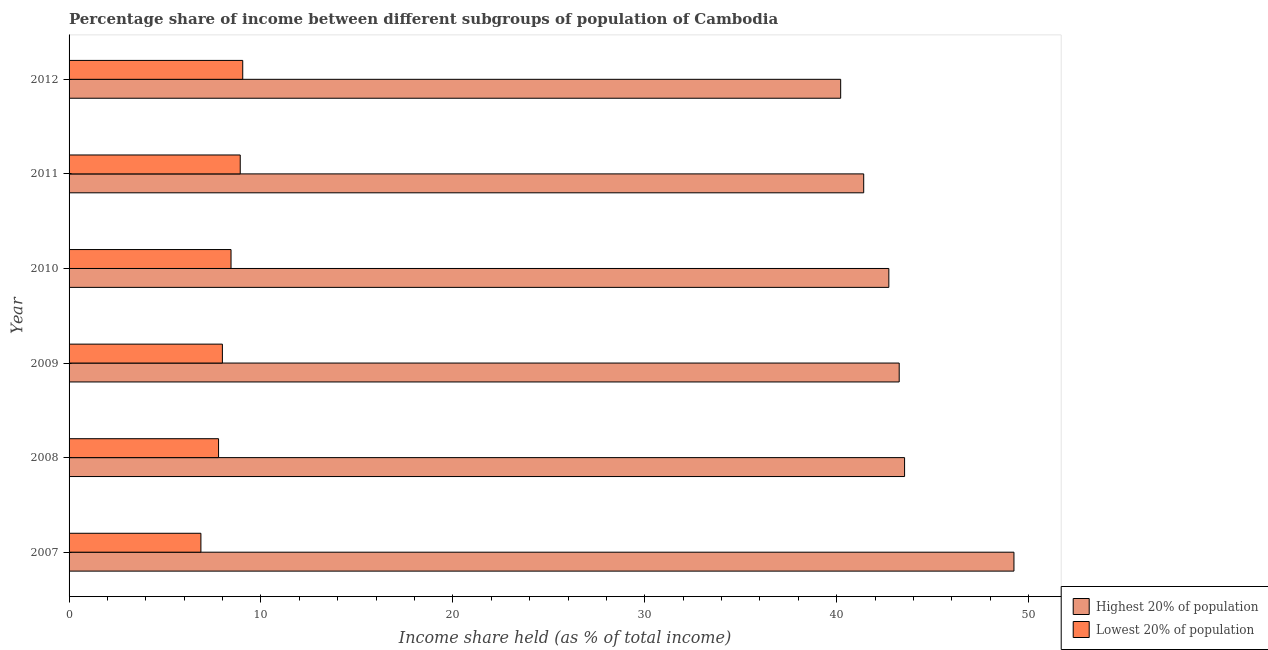How many different coloured bars are there?
Give a very brief answer. 2. Are the number of bars per tick equal to the number of legend labels?
Offer a terse response. Yes. Are the number of bars on each tick of the Y-axis equal?
Make the answer very short. Yes. How many bars are there on the 6th tick from the top?
Provide a short and direct response. 2. How many bars are there on the 5th tick from the bottom?
Offer a terse response. 2. What is the income share held by highest 20% of the population in 2012?
Your answer should be very brief. 40.21. Across all years, what is the maximum income share held by highest 20% of the population?
Ensure brevity in your answer.  49.24. Across all years, what is the minimum income share held by lowest 20% of the population?
Your response must be concise. 6.87. In which year was the income share held by lowest 20% of the population minimum?
Provide a succinct answer. 2007. What is the total income share held by lowest 20% of the population in the graph?
Give a very brief answer. 49.06. What is the difference between the income share held by highest 20% of the population in 2007 and that in 2011?
Your answer should be very brief. 7.83. What is the difference between the income share held by lowest 20% of the population in 2010 and the income share held by highest 20% of the population in 2007?
Provide a succinct answer. -40.8. What is the average income share held by lowest 20% of the population per year?
Ensure brevity in your answer.  8.18. In the year 2008, what is the difference between the income share held by lowest 20% of the population and income share held by highest 20% of the population?
Provide a short and direct response. -35.75. In how many years, is the income share held by highest 20% of the population greater than 34 %?
Give a very brief answer. 6. What is the ratio of the income share held by lowest 20% of the population in 2007 to that in 2009?
Your answer should be compact. 0.86. Is the income share held by highest 20% of the population in 2008 less than that in 2009?
Your answer should be compact. No. Is the difference between the income share held by highest 20% of the population in 2007 and 2012 greater than the difference between the income share held by lowest 20% of the population in 2007 and 2012?
Your answer should be compact. Yes. What is the difference between the highest and the second highest income share held by lowest 20% of the population?
Make the answer very short. 0.13. What is the difference between the highest and the lowest income share held by highest 20% of the population?
Give a very brief answer. 9.03. In how many years, is the income share held by lowest 20% of the population greater than the average income share held by lowest 20% of the population taken over all years?
Keep it short and to the point. 3. Is the sum of the income share held by lowest 20% of the population in 2007 and 2009 greater than the maximum income share held by highest 20% of the population across all years?
Keep it short and to the point. No. What does the 2nd bar from the top in 2009 represents?
Your answer should be very brief. Highest 20% of population. What does the 2nd bar from the bottom in 2011 represents?
Your answer should be very brief. Lowest 20% of population. Are all the bars in the graph horizontal?
Your response must be concise. Yes. What is the difference between two consecutive major ticks on the X-axis?
Offer a very short reply. 10. Are the values on the major ticks of X-axis written in scientific E-notation?
Ensure brevity in your answer.  No. Does the graph contain any zero values?
Your answer should be compact. No. How many legend labels are there?
Provide a succinct answer. 2. What is the title of the graph?
Your response must be concise. Percentage share of income between different subgroups of population of Cambodia. Does "Secondary Education" appear as one of the legend labels in the graph?
Provide a short and direct response. No. What is the label or title of the X-axis?
Ensure brevity in your answer.  Income share held (as % of total income). What is the Income share held (as % of total income) of Highest 20% of population in 2007?
Your answer should be compact. 49.24. What is the Income share held (as % of total income) in Lowest 20% of population in 2007?
Give a very brief answer. 6.87. What is the Income share held (as % of total income) in Highest 20% of population in 2008?
Provide a short and direct response. 43.54. What is the Income share held (as % of total income) of Lowest 20% of population in 2008?
Make the answer very short. 7.79. What is the Income share held (as % of total income) of Highest 20% of population in 2009?
Offer a terse response. 43.26. What is the Income share held (as % of total income) in Lowest 20% of population in 2009?
Your answer should be very brief. 7.99. What is the Income share held (as % of total income) in Highest 20% of population in 2010?
Keep it short and to the point. 42.72. What is the Income share held (as % of total income) of Lowest 20% of population in 2010?
Offer a terse response. 8.44. What is the Income share held (as % of total income) in Highest 20% of population in 2011?
Your answer should be compact. 41.41. What is the Income share held (as % of total income) in Lowest 20% of population in 2011?
Your answer should be compact. 8.92. What is the Income share held (as % of total income) in Highest 20% of population in 2012?
Your response must be concise. 40.21. What is the Income share held (as % of total income) in Lowest 20% of population in 2012?
Offer a terse response. 9.05. Across all years, what is the maximum Income share held (as % of total income) of Highest 20% of population?
Provide a succinct answer. 49.24. Across all years, what is the maximum Income share held (as % of total income) of Lowest 20% of population?
Your response must be concise. 9.05. Across all years, what is the minimum Income share held (as % of total income) in Highest 20% of population?
Offer a very short reply. 40.21. Across all years, what is the minimum Income share held (as % of total income) in Lowest 20% of population?
Make the answer very short. 6.87. What is the total Income share held (as % of total income) of Highest 20% of population in the graph?
Give a very brief answer. 260.38. What is the total Income share held (as % of total income) of Lowest 20% of population in the graph?
Ensure brevity in your answer.  49.06. What is the difference between the Income share held (as % of total income) in Lowest 20% of population in 2007 and that in 2008?
Your answer should be very brief. -0.92. What is the difference between the Income share held (as % of total income) in Highest 20% of population in 2007 and that in 2009?
Your answer should be very brief. 5.98. What is the difference between the Income share held (as % of total income) in Lowest 20% of population in 2007 and that in 2009?
Offer a terse response. -1.12. What is the difference between the Income share held (as % of total income) of Highest 20% of population in 2007 and that in 2010?
Provide a succinct answer. 6.52. What is the difference between the Income share held (as % of total income) in Lowest 20% of population in 2007 and that in 2010?
Your response must be concise. -1.57. What is the difference between the Income share held (as % of total income) in Highest 20% of population in 2007 and that in 2011?
Ensure brevity in your answer.  7.83. What is the difference between the Income share held (as % of total income) in Lowest 20% of population in 2007 and that in 2011?
Provide a short and direct response. -2.05. What is the difference between the Income share held (as % of total income) in Highest 20% of population in 2007 and that in 2012?
Your answer should be compact. 9.03. What is the difference between the Income share held (as % of total income) of Lowest 20% of population in 2007 and that in 2012?
Your response must be concise. -2.18. What is the difference between the Income share held (as % of total income) of Highest 20% of population in 2008 and that in 2009?
Make the answer very short. 0.28. What is the difference between the Income share held (as % of total income) of Highest 20% of population in 2008 and that in 2010?
Your answer should be very brief. 0.82. What is the difference between the Income share held (as % of total income) of Lowest 20% of population in 2008 and that in 2010?
Give a very brief answer. -0.65. What is the difference between the Income share held (as % of total income) of Highest 20% of population in 2008 and that in 2011?
Make the answer very short. 2.13. What is the difference between the Income share held (as % of total income) in Lowest 20% of population in 2008 and that in 2011?
Keep it short and to the point. -1.13. What is the difference between the Income share held (as % of total income) of Highest 20% of population in 2008 and that in 2012?
Ensure brevity in your answer.  3.33. What is the difference between the Income share held (as % of total income) in Lowest 20% of population in 2008 and that in 2012?
Your response must be concise. -1.26. What is the difference between the Income share held (as % of total income) of Highest 20% of population in 2009 and that in 2010?
Your answer should be compact. 0.54. What is the difference between the Income share held (as % of total income) of Lowest 20% of population in 2009 and that in 2010?
Provide a succinct answer. -0.45. What is the difference between the Income share held (as % of total income) of Highest 20% of population in 2009 and that in 2011?
Give a very brief answer. 1.85. What is the difference between the Income share held (as % of total income) in Lowest 20% of population in 2009 and that in 2011?
Keep it short and to the point. -0.93. What is the difference between the Income share held (as % of total income) of Highest 20% of population in 2009 and that in 2012?
Give a very brief answer. 3.05. What is the difference between the Income share held (as % of total income) in Lowest 20% of population in 2009 and that in 2012?
Your response must be concise. -1.06. What is the difference between the Income share held (as % of total income) of Highest 20% of population in 2010 and that in 2011?
Your answer should be compact. 1.31. What is the difference between the Income share held (as % of total income) of Lowest 20% of population in 2010 and that in 2011?
Provide a succinct answer. -0.48. What is the difference between the Income share held (as % of total income) of Highest 20% of population in 2010 and that in 2012?
Your answer should be compact. 2.51. What is the difference between the Income share held (as % of total income) of Lowest 20% of population in 2010 and that in 2012?
Offer a terse response. -0.61. What is the difference between the Income share held (as % of total income) of Highest 20% of population in 2011 and that in 2012?
Keep it short and to the point. 1.2. What is the difference between the Income share held (as % of total income) in Lowest 20% of population in 2011 and that in 2012?
Your answer should be very brief. -0.13. What is the difference between the Income share held (as % of total income) in Highest 20% of population in 2007 and the Income share held (as % of total income) in Lowest 20% of population in 2008?
Give a very brief answer. 41.45. What is the difference between the Income share held (as % of total income) of Highest 20% of population in 2007 and the Income share held (as % of total income) of Lowest 20% of population in 2009?
Make the answer very short. 41.25. What is the difference between the Income share held (as % of total income) in Highest 20% of population in 2007 and the Income share held (as % of total income) in Lowest 20% of population in 2010?
Offer a very short reply. 40.8. What is the difference between the Income share held (as % of total income) of Highest 20% of population in 2007 and the Income share held (as % of total income) of Lowest 20% of population in 2011?
Make the answer very short. 40.32. What is the difference between the Income share held (as % of total income) in Highest 20% of population in 2007 and the Income share held (as % of total income) in Lowest 20% of population in 2012?
Your answer should be compact. 40.19. What is the difference between the Income share held (as % of total income) in Highest 20% of population in 2008 and the Income share held (as % of total income) in Lowest 20% of population in 2009?
Provide a succinct answer. 35.55. What is the difference between the Income share held (as % of total income) in Highest 20% of population in 2008 and the Income share held (as % of total income) in Lowest 20% of population in 2010?
Your response must be concise. 35.1. What is the difference between the Income share held (as % of total income) in Highest 20% of population in 2008 and the Income share held (as % of total income) in Lowest 20% of population in 2011?
Ensure brevity in your answer.  34.62. What is the difference between the Income share held (as % of total income) of Highest 20% of population in 2008 and the Income share held (as % of total income) of Lowest 20% of population in 2012?
Ensure brevity in your answer.  34.49. What is the difference between the Income share held (as % of total income) in Highest 20% of population in 2009 and the Income share held (as % of total income) in Lowest 20% of population in 2010?
Give a very brief answer. 34.82. What is the difference between the Income share held (as % of total income) of Highest 20% of population in 2009 and the Income share held (as % of total income) of Lowest 20% of population in 2011?
Ensure brevity in your answer.  34.34. What is the difference between the Income share held (as % of total income) in Highest 20% of population in 2009 and the Income share held (as % of total income) in Lowest 20% of population in 2012?
Give a very brief answer. 34.21. What is the difference between the Income share held (as % of total income) of Highest 20% of population in 2010 and the Income share held (as % of total income) of Lowest 20% of population in 2011?
Provide a succinct answer. 33.8. What is the difference between the Income share held (as % of total income) of Highest 20% of population in 2010 and the Income share held (as % of total income) of Lowest 20% of population in 2012?
Your answer should be very brief. 33.67. What is the difference between the Income share held (as % of total income) of Highest 20% of population in 2011 and the Income share held (as % of total income) of Lowest 20% of population in 2012?
Your answer should be very brief. 32.36. What is the average Income share held (as % of total income) in Highest 20% of population per year?
Offer a very short reply. 43.4. What is the average Income share held (as % of total income) in Lowest 20% of population per year?
Offer a very short reply. 8.18. In the year 2007, what is the difference between the Income share held (as % of total income) in Highest 20% of population and Income share held (as % of total income) in Lowest 20% of population?
Your response must be concise. 42.37. In the year 2008, what is the difference between the Income share held (as % of total income) of Highest 20% of population and Income share held (as % of total income) of Lowest 20% of population?
Give a very brief answer. 35.75. In the year 2009, what is the difference between the Income share held (as % of total income) of Highest 20% of population and Income share held (as % of total income) of Lowest 20% of population?
Offer a very short reply. 35.27. In the year 2010, what is the difference between the Income share held (as % of total income) in Highest 20% of population and Income share held (as % of total income) in Lowest 20% of population?
Your answer should be very brief. 34.28. In the year 2011, what is the difference between the Income share held (as % of total income) in Highest 20% of population and Income share held (as % of total income) in Lowest 20% of population?
Make the answer very short. 32.49. In the year 2012, what is the difference between the Income share held (as % of total income) in Highest 20% of population and Income share held (as % of total income) in Lowest 20% of population?
Your answer should be very brief. 31.16. What is the ratio of the Income share held (as % of total income) of Highest 20% of population in 2007 to that in 2008?
Provide a succinct answer. 1.13. What is the ratio of the Income share held (as % of total income) in Lowest 20% of population in 2007 to that in 2008?
Offer a very short reply. 0.88. What is the ratio of the Income share held (as % of total income) of Highest 20% of population in 2007 to that in 2009?
Your response must be concise. 1.14. What is the ratio of the Income share held (as % of total income) in Lowest 20% of population in 2007 to that in 2009?
Your answer should be compact. 0.86. What is the ratio of the Income share held (as % of total income) of Highest 20% of population in 2007 to that in 2010?
Give a very brief answer. 1.15. What is the ratio of the Income share held (as % of total income) in Lowest 20% of population in 2007 to that in 2010?
Provide a short and direct response. 0.81. What is the ratio of the Income share held (as % of total income) in Highest 20% of population in 2007 to that in 2011?
Your response must be concise. 1.19. What is the ratio of the Income share held (as % of total income) of Lowest 20% of population in 2007 to that in 2011?
Provide a succinct answer. 0.77. What is the ratio of the Income share held (as % of total income) of Highest 20% of population in 2007 to that in 2012?
Keep it short and to the point. 1.22. What is the ratio of the Income share held (as % of total income) in Lowest 20% of population in 2007 to that in 2012?
Your response must be concise. 0.76. What is the ratio of the Income share held (as % of total income) in Lowest 20% of population in 2008 to that in 2009?
Keep it short and to the point. 0.97. What is the ratio of the Income share held (as % of total income) in Highest 20% of population in 2008 to that in 2010?
Your answer should be very brief. 1.02. What is the ratio of the Income share held (as % of total income) of Lowest 20% of population in 2008 to that in 2010?
Make the answer very short. 0.92. What is the ratio of the Income share held (as % of total income) of Highest 20% of population in 2008 to that in 2011?
Make the answer very short. 1.05. What is the ratio of the Income share held (as % of total income) in Lowest 20% of population in 2008 to that in 2011?
Your answer should be compact. 0.87. What is the ratio of the Income share held (as % of total income) of Highest 20% of population in 2008 to that in 2012?
Make the answer very short. 1.08. What is the ratio of the Income share held (as % of total income) of Lowest 20% of population in 2008 to that in 2012?
Offer a terse response. 0.86. What is the ratio of the Income share held (as % of total income) of Highest 20% of population in 2009 to that in 2010?
Offer a very short reply. 1.01. What is the ratio of the Income share held (as % of total income) of Lowest 20% of population in 2009 to that in 2010?
Make the answer very short. 0.95. What is the ratio of the Income share held (as % of total income) in Highest 20% of population in 2009 to that in 2011?
Your answer should be compact. 1.04. What is the ratio of the Income share held (as % of total income) in Lowest 20% of population in 2009 to that in 2011?
Keep it short and to the point. 0.9. What is the ratio of the Income share held (as % of total income) of Highest 20% of population in 2009 to that in 2012?
Your answer should be compact. 1.08. What is the ratio of the Income share held (as % of total income) of Lowest 20% of population in 2009 to that in 2012?
Your response must be concise. 0.88. What is the ratio of the Income share held (as % of total income) of Highest 20% of population in 2010 to that in 2011?
Give a very brief answer. 1.03. What is the ratio of the Income share held (as % of total income) in Lowest 20% of population in 2010 to that in 2011?
Offer a very short reply. 0.95. What is the ratio of the Income share held (as % of total income) of Highest 20% of population in 2010 to that in 2012?
Ensure brevity in your answer.  1.06. What is the ratio of the Income share held (as % of total income) in Lowest 20% of population in 2010 to that in 2012?
Make the answer very short. 0.93. What is the ratio of the Income share held (as % of total income) of Highest 20% of population in 2011 to that in 2012?
Ensure brevity in your answer.  1.03. What is the ratio of the Income share held (as % of total income) of Lowest 20% of population in 2011 to that in 2012?
Offer a terse response. 0.99. What is the difference between the highest and the second highest Income share held (as % of total income) of Highest 20% of population?
Offer a very short reply. 5.7. What is the difference between the highest and the second highest Income share held (as % of total income) in Lowest 20% of population?
Your response must be concise. 0.13. What is the difference between the highest and the lowest Income share held (as % of total income) of Highest 20% of population?
Provide a short and direct response. 9.03. What is the difference between the highest and the lowest Income share held (as % of total income) of Lowest 20% of population?
Offer a terse response. 2.18. 